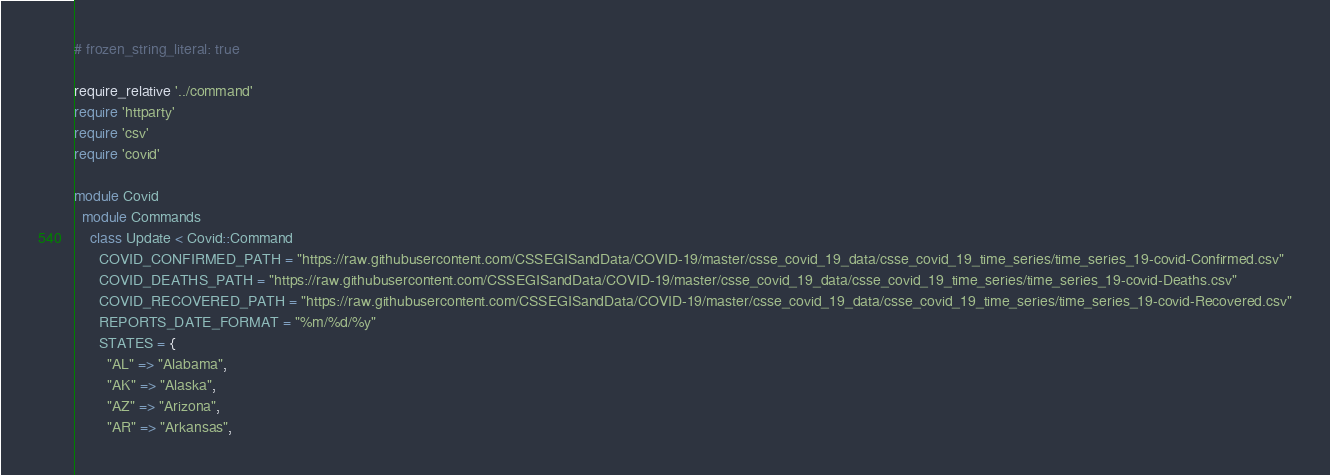<code> <loc_0><loc_0><loc_500><loc_500><_Ruby_># frozen_string_literal: true

require_relative '../command'
require 'httparty'
require 'csv'
require 'covid'

module Covid
  module Commands
    class Update < Covid::Command
      COVID_CONFIRMED_PATH = "https://raw.githubusercontent.com/CSSEGISandData/COVID-19/master/csse_covid_19_data/csse_covid_19_time_series/time_series_19-covid-Confirmed.csv"
      COVID_DEATHS_PATH = "https://raw.githubusercontent.com/CSSEGISandData/COVID-19/master/csse_covid_19_data/csse_covid_19_time_series/time_series_19-covid-Deaths.csv"
      COVID_RECOVERED_PATH = "https://raw.githubusercontent.com/CSSEGISandData/COVID-19/master/csse_covid_19_data/csse_covid_19_time_series/time_series_19-covid-Recovered.csv"
      REPORTS_DATE_FORMAT = "%m/%d/%y"
      STATES = {
        "AL" => "Alabama",
        "AK" => "Alaska",
        "AZ" => "Arizona",
        "AR" => "Arkansas",</code> 